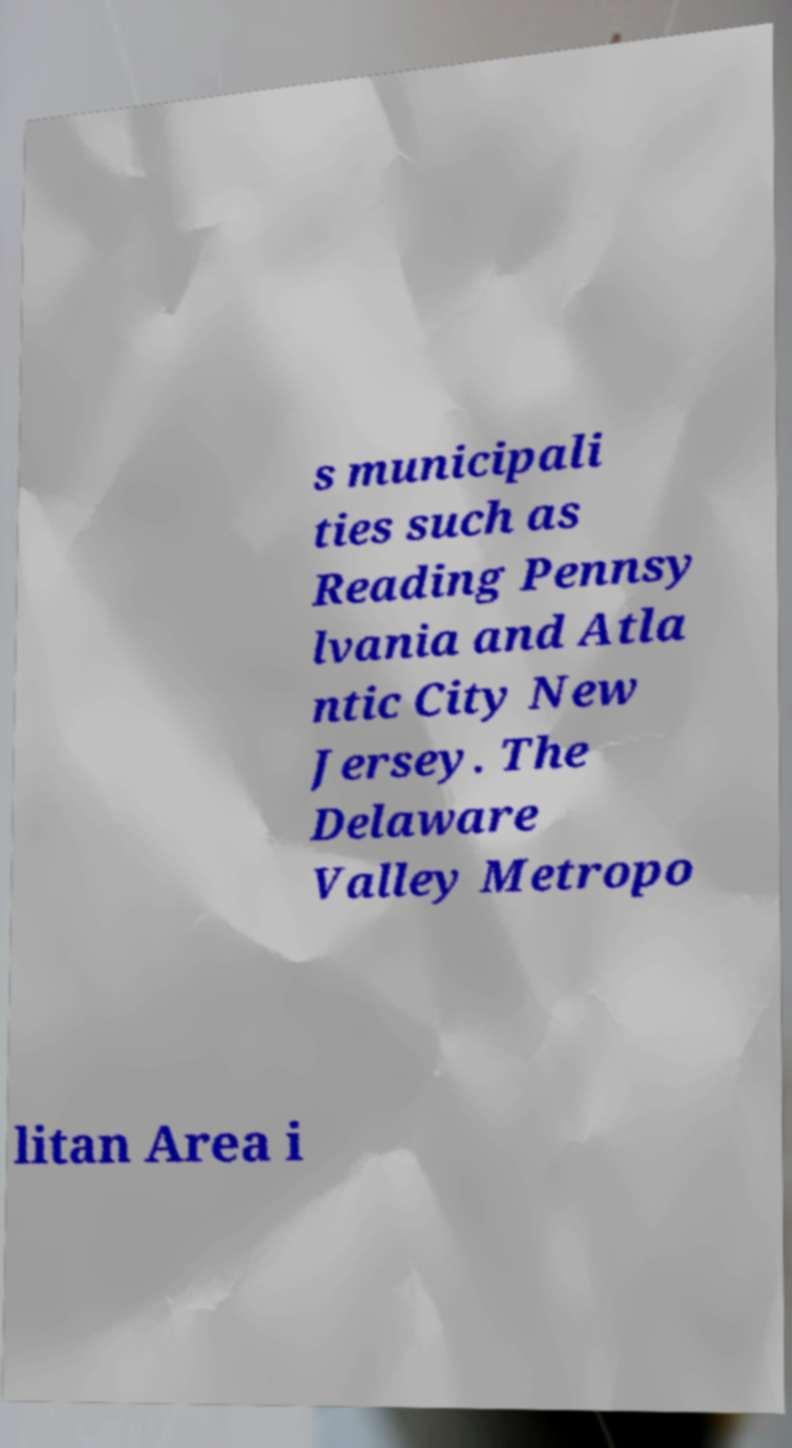Please read and relay the text visible in this image. What does it say? s municipali ties such as Reading Pennsy lvania and Atla ntic City New Jersey. The Delaware Valley Metropo litan Area i 